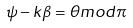Convert formula to latex. <formula><loc_0><loc_0><loc_500><loc_500>\psi - k \beta = \theta m o d \pi</formula> 